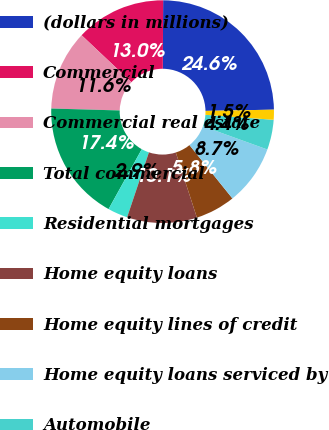Convert chart to OTSL. <chart><loc_0><loc_0><loc_500><loc_500><pie_chart><fcel>(dollars in millions)<fcel>Commercial<fcel>Commercial real estate<fcel>Total commercial<fcel>Residential mortgages<fcel>Home equity loans<fcel>Home equity lines of credit<fcel>Home equity loans serviced by<fcel>Automobile<fcel>Credit cards<nl><fcel>24.63%<fcel>13.04%<fcel>11.59%<fcel>17.39%<fcel>2.9%<fcel>10.14%<fcel>5.8%<fcel>8.7%<fcel>4.35%<fcel>1.45%<nl></chart> 